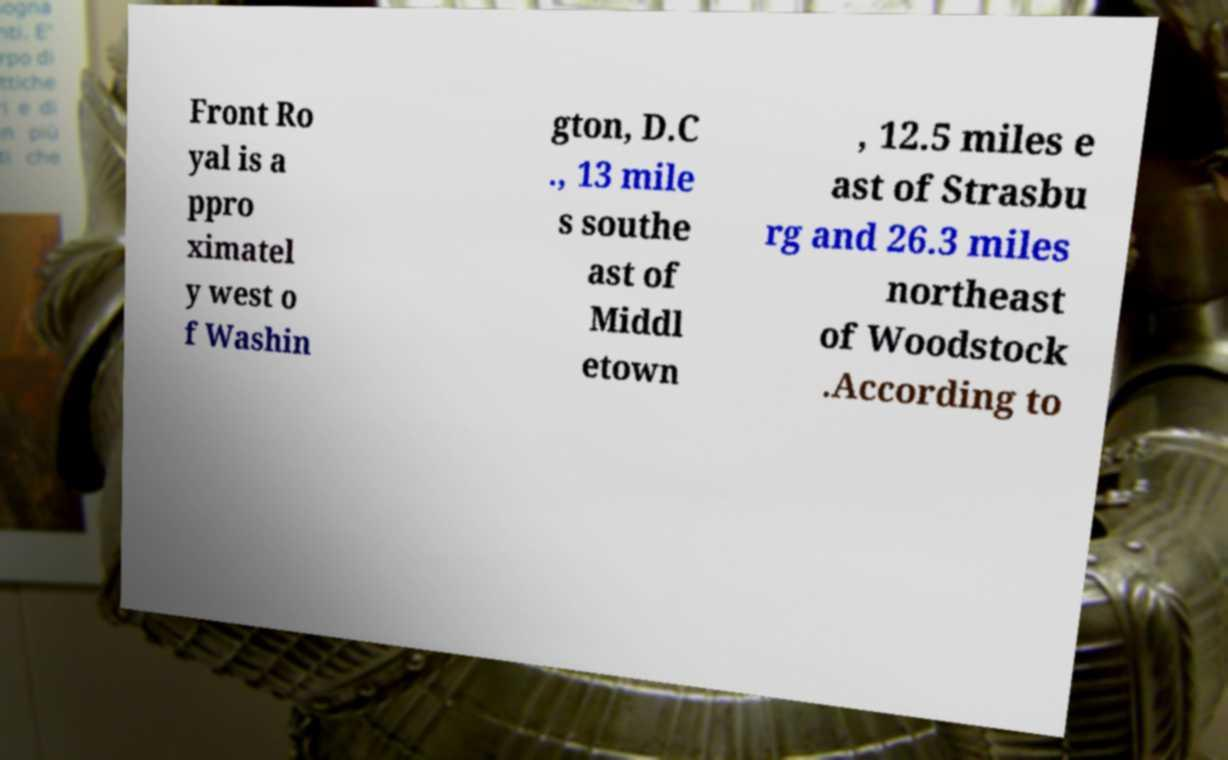Could you assist in decoding the text presented in this image and type it out clearly? Front Ro yal is a ppro ximatel y west o f Washin gton, D.C ., 13 mile s southe ast of Middl etown , 12.5 miles e ast of Strasbu rg and 26.3 miles northeast of Woodstock .According to 